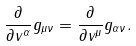Convert formula to latex. <formula><loc_0><loc_0><loc_500><loc_500>\frac { \partial } { \partial v ^ { \alpha } } g _ { \mu \nu } = \frac { \partial } { \partial v ^ { \mu } } g _ { \alpha \nu } .</formula> 